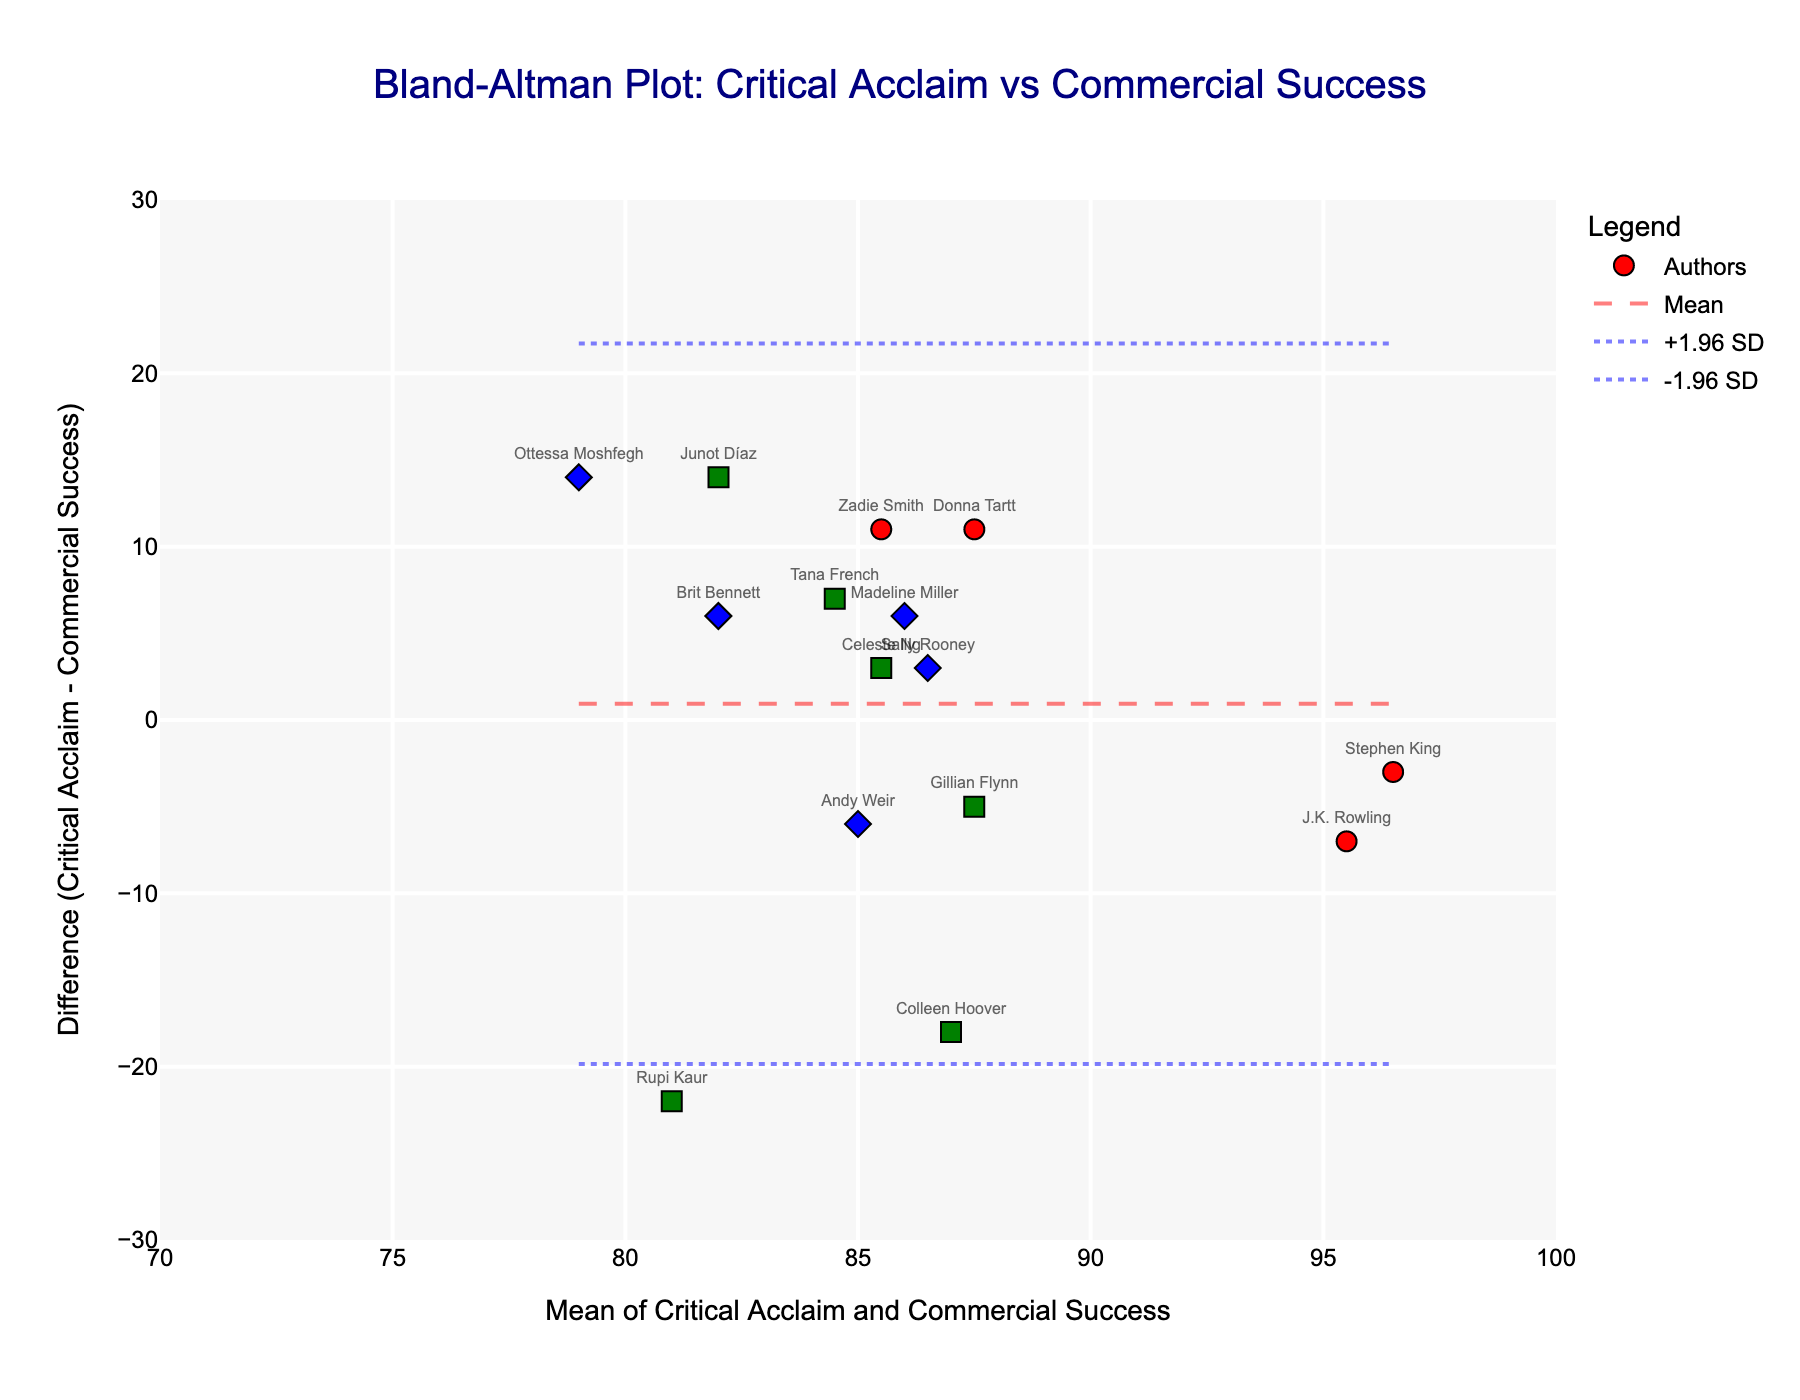what is the title of the plot? The title of the plot is located at the top center of the figure and reads "Bland-Altman Plot: Critical Acclaim vs Commercial Success".
Answer: Bland-Altman Plot: Critical Acclaim vs Commercial Success How many authors are labeled in the plot? By counting the number of markers, we can see that there are 15 data points, each representing an author.
Answer: 15 Which author has the largest positive difference between critical acclaim and commercial success scores? Look for the author positioned the highest on the y-axis, as the y-axis represents the difference (Critical Acclaim - Commercial Success). J.K. Rowling has the largest positive difference.
Answer: J.K. Rowling What is the mean difference between critical acclaim and commercial success scores? The mean difference is indicated by the dashed line on the y-axis. The value of this line represents the mean difference.
Answer: Mean line represents the mean difference of -4.0 What color represents mid-career authors? By observing the color legend or markers, it can be seen that the mid-career authors are represented by green markers.
Answer: green Which two career stages have their data points closest to the mean difference line? Look for the markers closest to the dashed mean difference line. Established and Mid-career authors have several points near the line.
Answer: Established and Mid-career What is the range of the x-axis? The x-axis represents the mean of critical acclaim and commercial success scores, and it ranges from 70 to 100.
Answer: 70 to 100 Which career stage has the most negative difference between scores? Look at the author's markers closest to the bottom of the y-axis where differences are most negative. Rising Stars have the most negative difference.
Answer: Rising Star Which rising star author has a higher mean score, Madeline Miller or Ottessa Moshfegh? Compare the x-axis values (mean score) of the markers labeled "Madeline Miller" and "Ottessa Moshfegh". Madeline Miller has a higher mean score.
Answer: Madeline Miller 